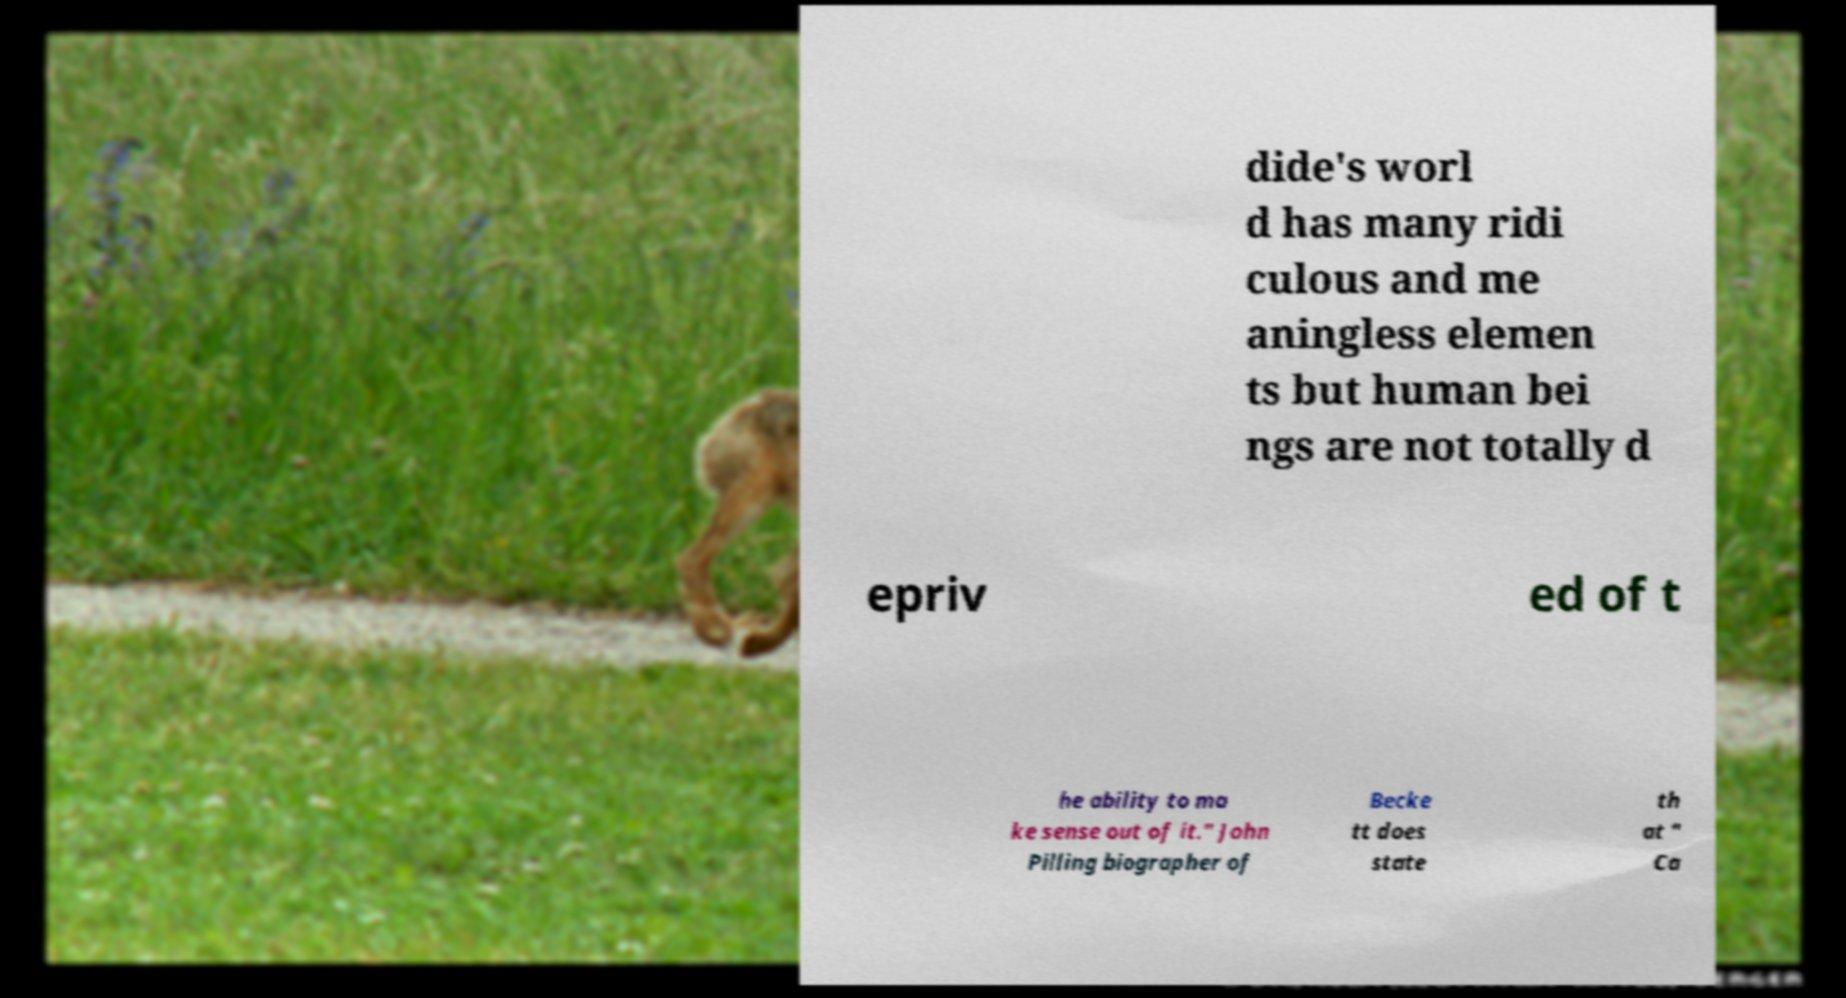Could you assist in decoding the text presented in this image and type it out clearly? dide's worl d has many ridi culous and me aningless elemen ts but human bei ngs are not totally d epriv ed of t he ability to ma ke sense out of it." John Pilling biographer of Becke tt does state th at " Ca 